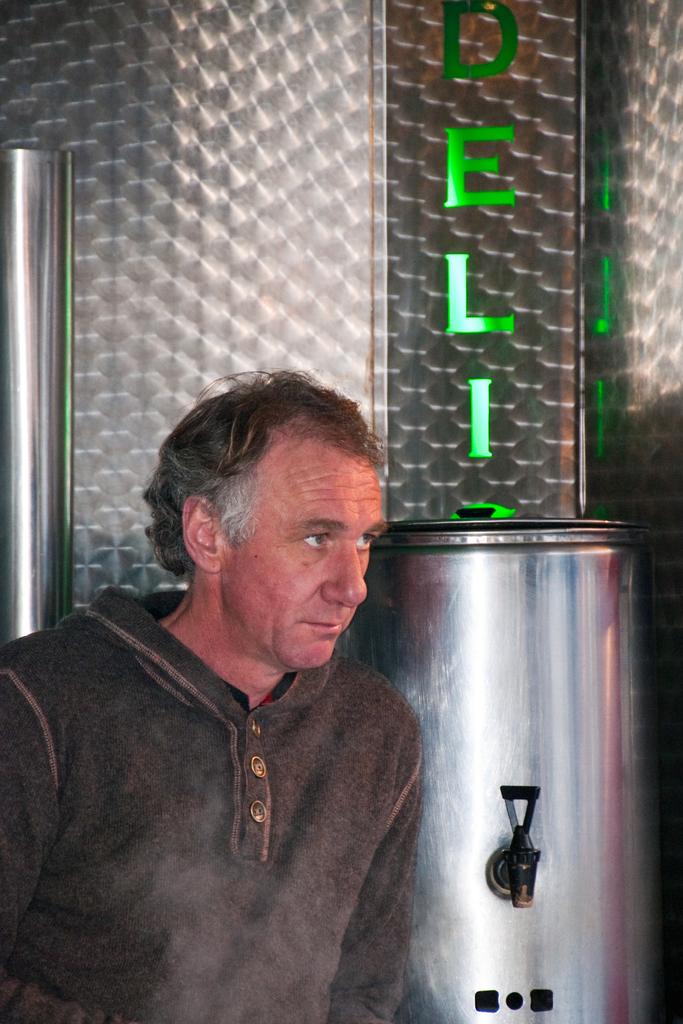What section is this man standing in?
Provide a short and direct response. Deli. Is that another letter under the word deli?
Offer a terse response. Unanswerable. 